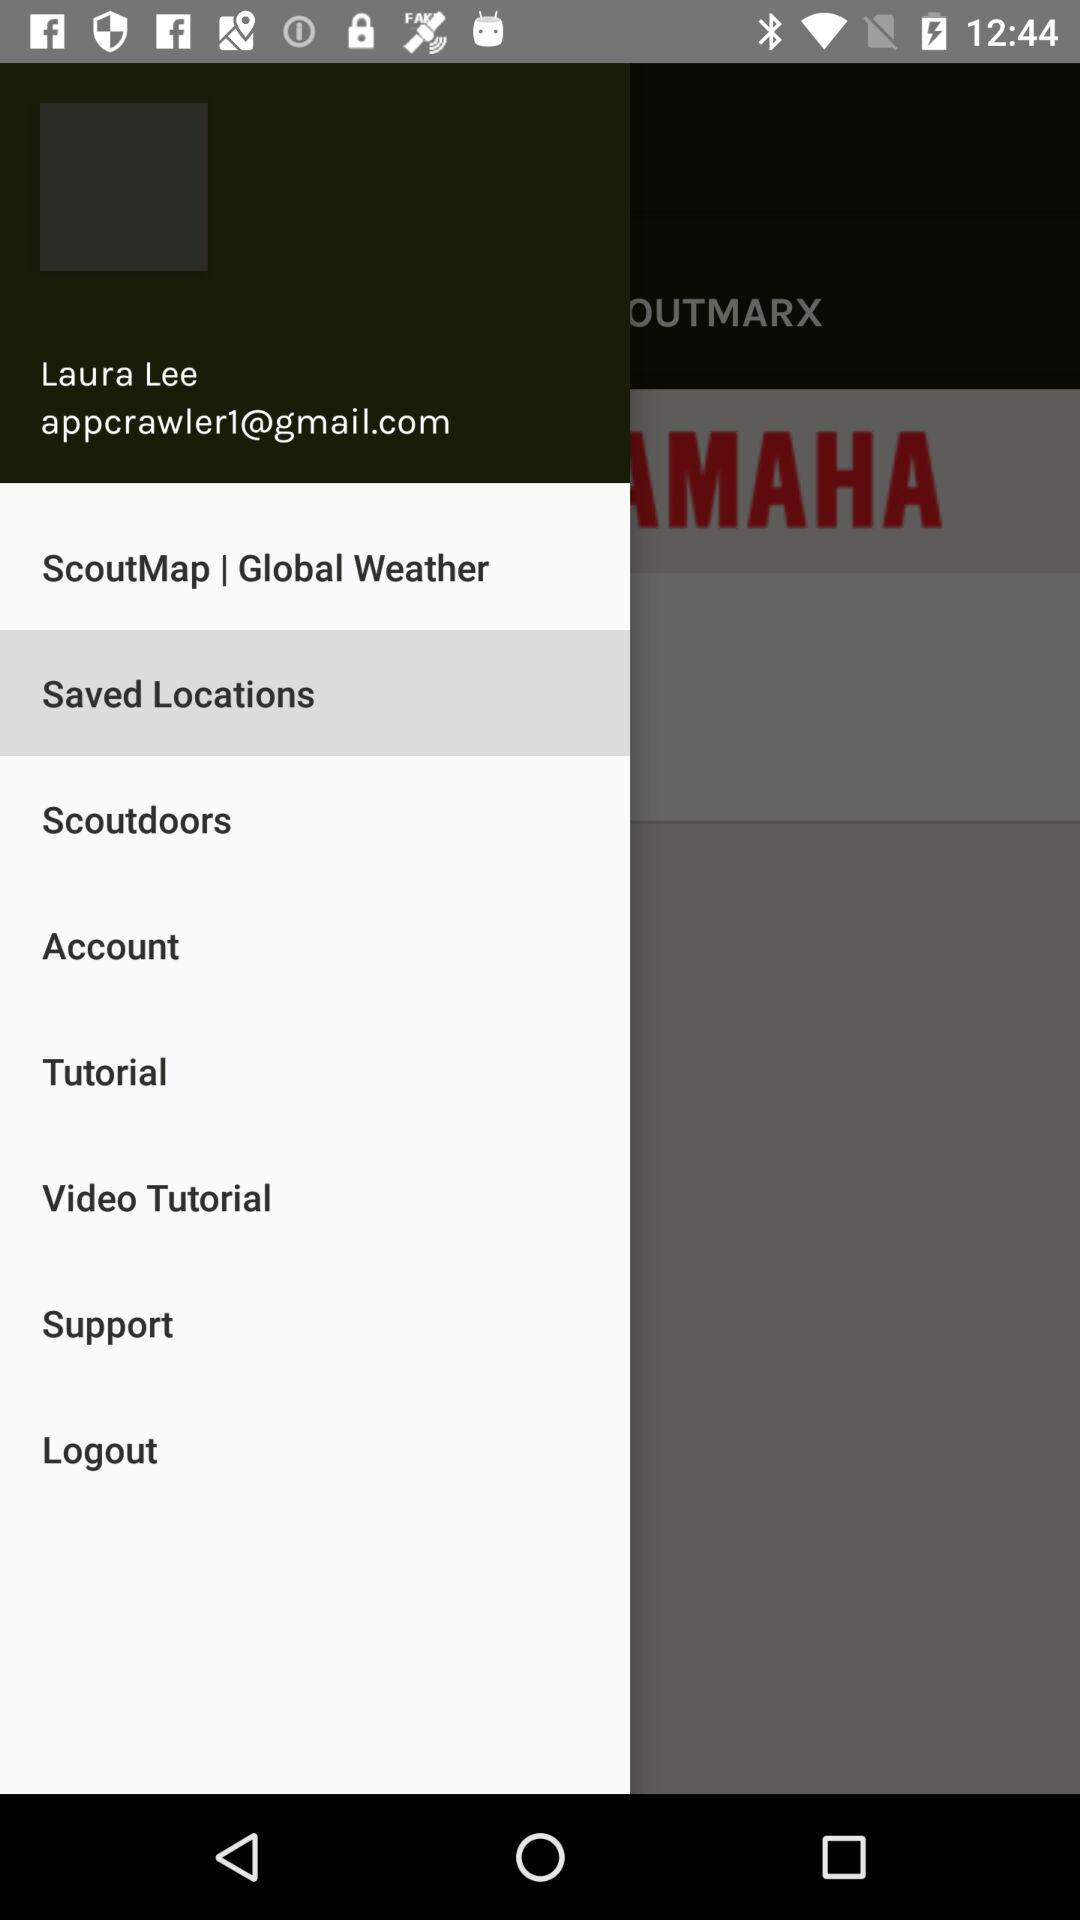What is the user name? The user name is Laura Lee. 